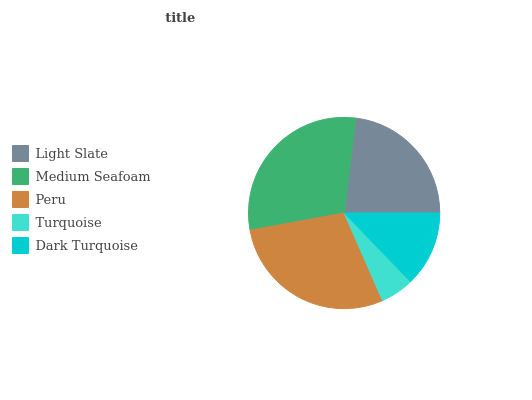Is Turquoise the minimum?
Answer yes or no. Yes. Is Medium Seafoam the maximum?
Answer yes or no. Yes. Is Peru the minimum?
Answer yes or no. No. Is Peru the maximum?
Answer yes or no. No. Is Medium Seafoam greater than Peru?
Answer yes or no. Yes. Is Peru less than Medium Seafoam?
Answer yes or no. Yes. Is Peru greater than Medium Seafoam?
Answer yes or no. No. Is Medium Seafoam less than Peru?
Answer yes or no. No. Is Light Slate the high median?
Answer yes or no. Yes. Is Light Slate the low median?
Answer yes or no. Yes. Is Turquoise the high median?
Answer yes or no. No. Is Peru the low median?
Answer yes or no. No. 